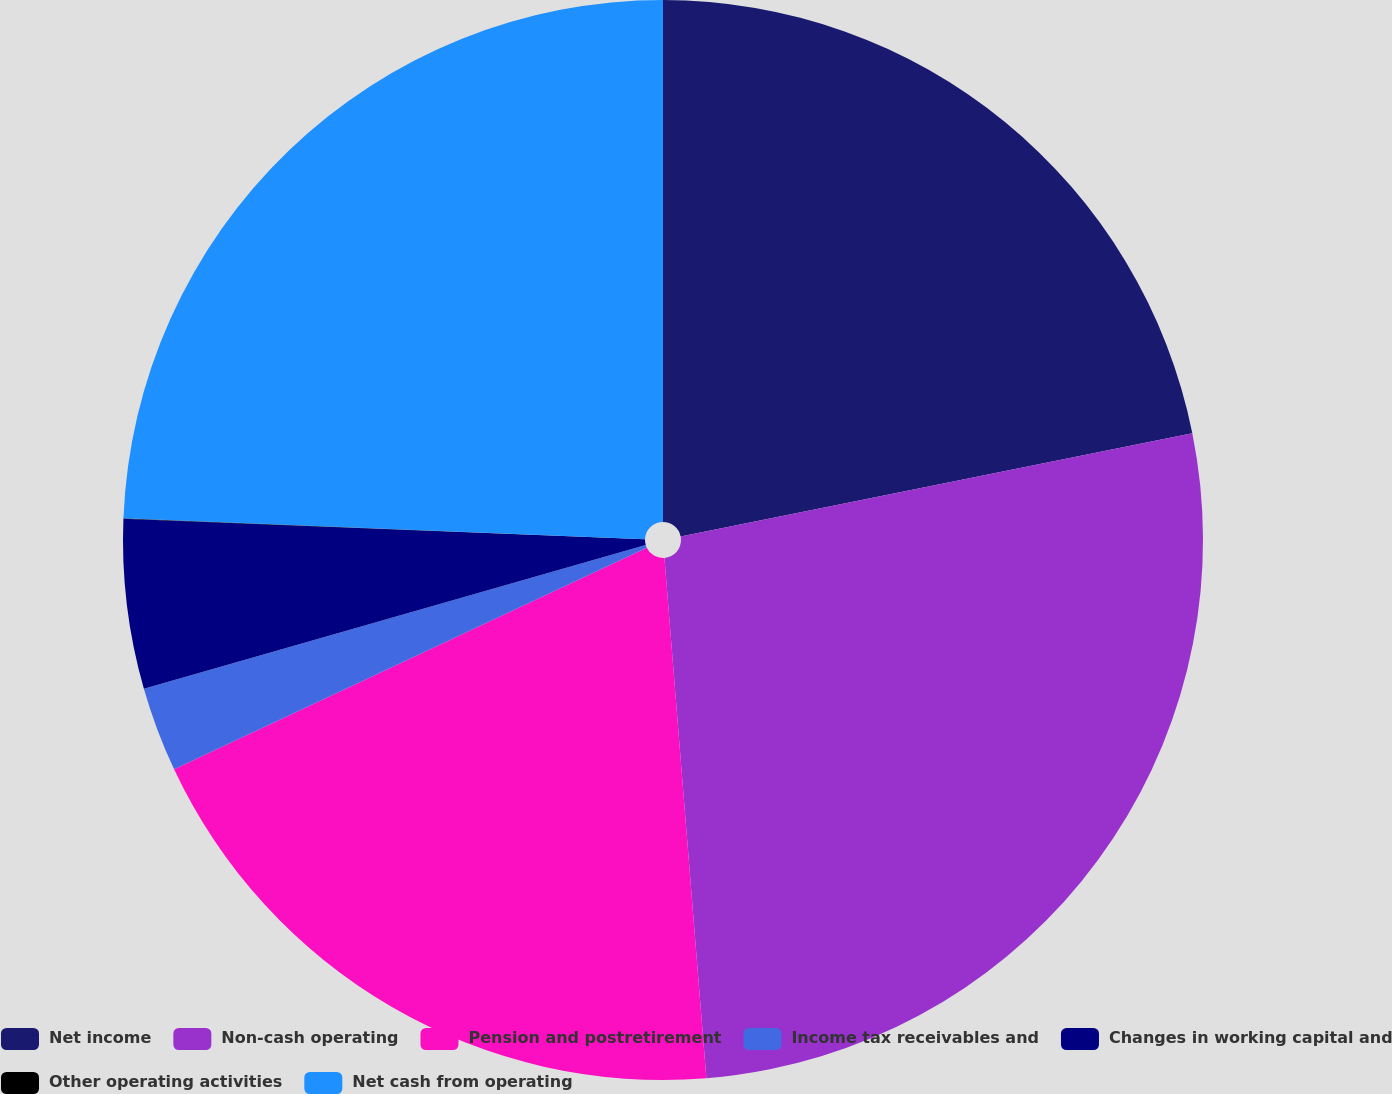<chart> <loc_0><loc_0><loc_500><loc_500><pie_chart><fcel>Net income<fcel>Non-cash operating<fcel>Pension and postretirement<fcel>Income tax receivables and<fcel>Changes in working capital and<fcel>Other operating activities<fcel>Net cash from operating<nl><fcel>21.83%<fcel>26.89%<fcel>19.3%<fcel>2.54%<fcel>5.07%<fcel>0.01%<fcel>24.36%<nl></chart> 